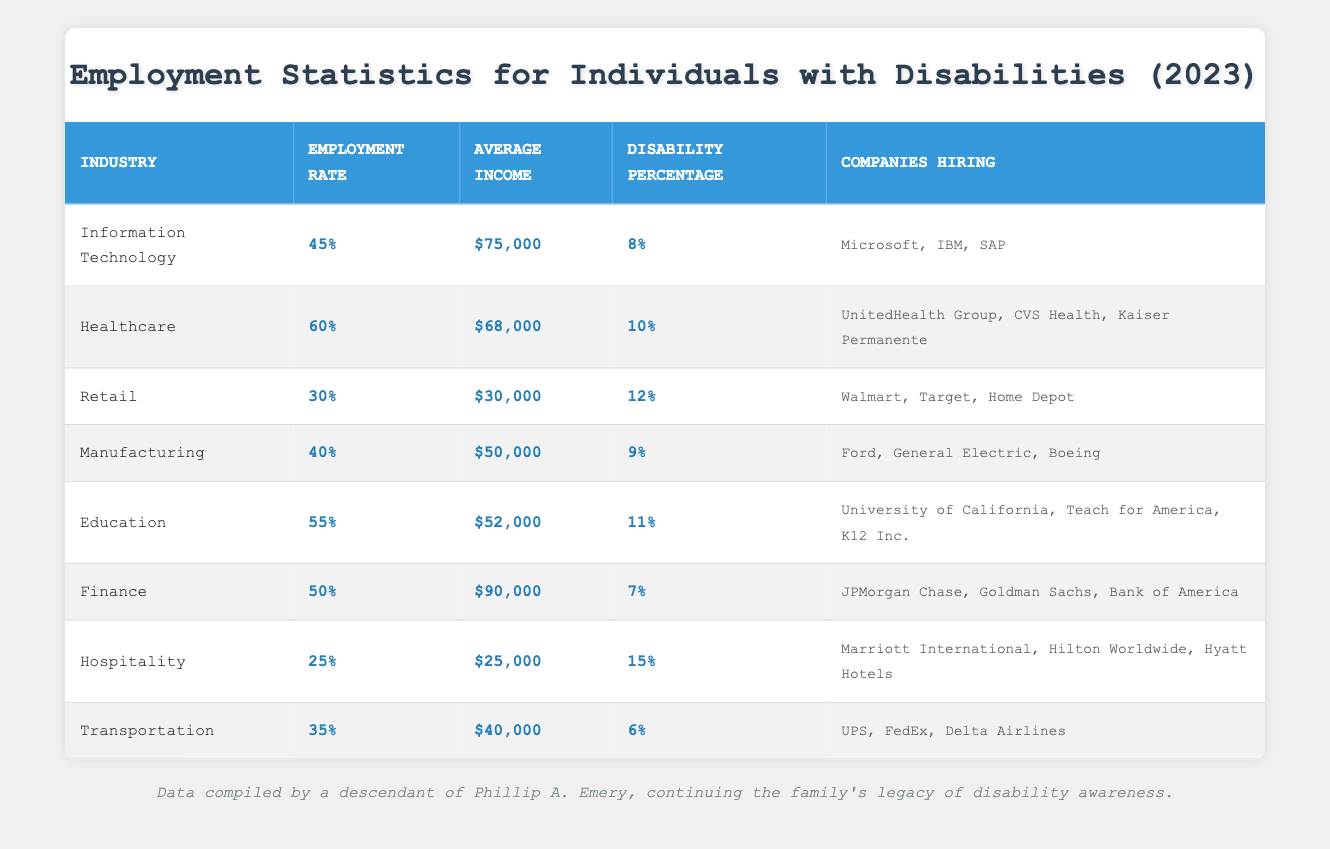What is the employment rate for individuals with disabilities in the Healthcare industry? The table provides a specific employment rate of 60% for the Healthcare industry in the corresponding row.
Answer: 60% Which industry has the highest average income for individuals with disabilities? By comparing the average incomes listed in the table, the Finance industry has the highest average income at $90,000.
Answer: Finance What percentage of individuals with disabilities are employed in the Transportation industry? The employment rate for the Transportation industry is explicitly noted as 35% in the table.
Answer: 35% What is the average income across all listed industries? To calculate the average income: (75000 + 68000 + 30000 + 50000 + 52000 + 90000 + 25000 + 40000) = 410000, and then divide by the number of industries (8). So, 410000 / 8 = 51250.
Answer: 51250 Which industry has the lowest employment rate for individuals with disabilities? By examining the employment rates in the table, Retail shows the lowest rate at 30%.
Answer: Retail Is it true that more than 10% of individuals with disabilities are employed in the Education industry? The table indicates that the Education industry has an employment rate of 55%, which is indeed more than 10%.
Answer: Yes Calculate the difference in employment rates between the Healthcare and Hospitality industries. The Healthcare employment rate is 60% and the Hospitality employment rate is 25%. So, the difference is 60% - 25% = 35%.
Answer: 35% Which companies are hiring for the Manufacturing industry? The table lists Ford, General Electric, and Boeing as the companies hiring in the Manufacturing sector.
Answer: Ford, General Electric, Boeing What is the total disability percentage across all listed industries? By adding the disability percentages: 8% + 10% + 12% + 9% + 11% + 7% + 15% + 6% = 78%.
Answer: 78% Which industry has a higher average income, Information Technology or Manufacturing? The average income of Information Technology is $75,000, and for Manufacturing, it is $50,000. Since $75,000 is greater than $50,000, Information Technology has a higher income.
Answer: Information Technology 